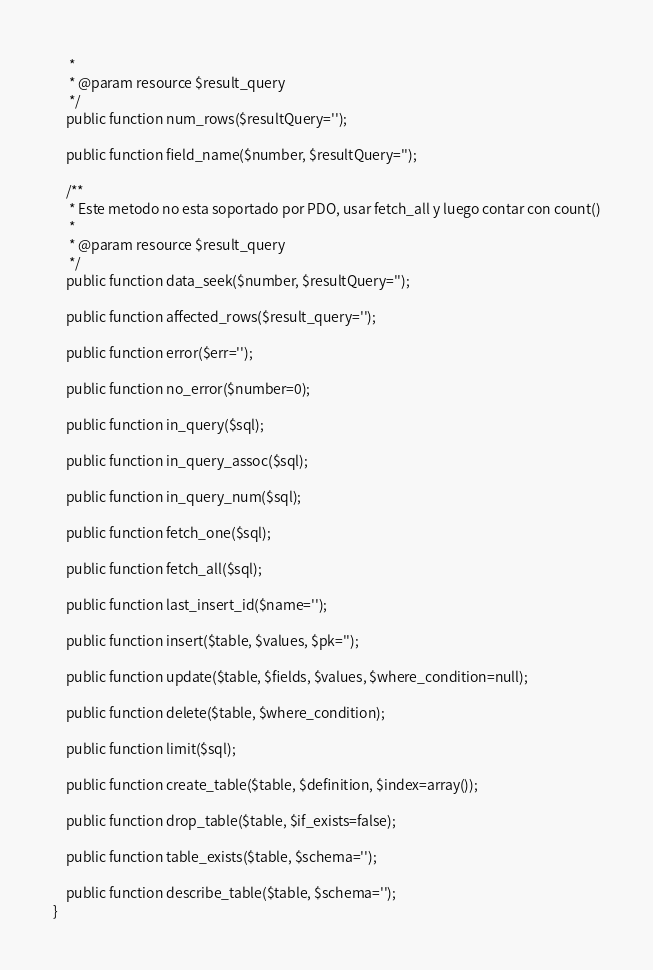<code> <loc_0><loc_0><loc_500><loc_500><_PHP_>     *
     * @param resource $result_query
     */
    public function num_rows($resultQuery='');

    public function field_name($number, $resultQuery='');

    /**
     * Este metodo no esta soportado por PDO, usar fetch_all y luego contar con count()
     *
     * @param resource $result_query
     */
    public function data_seek($number, $resultQuery='');

    public function affected_rows($result_query='');

    public function error($err='');

    public function no_error($number=0);

    public function in_query($sql);

    public function in_query_assoc($sql);

    public function in_query_num($sql);

    public function fetch_one($sql);

    public function fetch_all($sql);

    public function last_insert_id($name='');

    public function insert($table, $values, $pk='');

    public function update($table, $fields, $values, $where_condition=null);

    public function delete($table, $where_condition);

    public function limit($sql);

    public function create_table($table, $definition, $index=array());

    public function drop_table($table, $if_exists=false);

    public function table_exists($table, $schema='');

    public function describe_table($table, $schema='');
}
</code> 